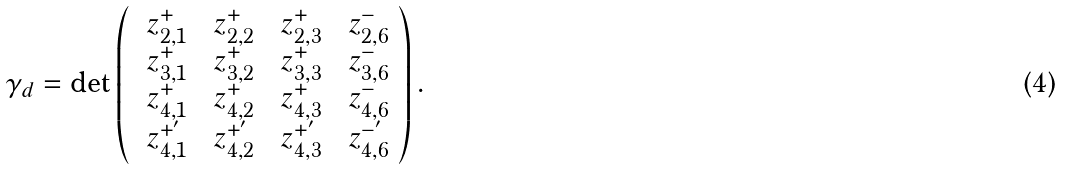Convert formula to latex. <formula><loc_0><loc_0><loc_500><loc_500>\gamma _ { d } = \det \left ( \begin{array} { c c c c } \ z _ { 2 , 1 } ^ { + } & \ z _ { 2 , 2 } ^ { + } & \ z _ { 2 , 3 } ^ { + } & \ z _ { 2 , 6 } ^ { - } \\ \ z _ { 3 , 1 } ^ { + } & \ z _ { 3 , 2 } ^ { + } & \ z _ { 3 , 3 } ^ { + } & \ z _ { 3 , 6 } ^ { - } \\ \ z _ { 4 , 1 } ^ { + } & \ z _ { 4 , 2 } ^ { + } & \ z _ { 4 , 3 } ^ { + } & \ z _ { 4 , 6 } ^ { - } \\ \ z _ { 4 , 1 } ^ { + ^ { \prime } } & \ z _ { 4 , 2 } ^ { + ^ { \prime } } & \ z _ { 4 , 3 } ^ { + ^ { \prime } } & \ z _ { 4 , 6 } ^ { - ^ { \prime } } \end{array} \right ) .</formula> 